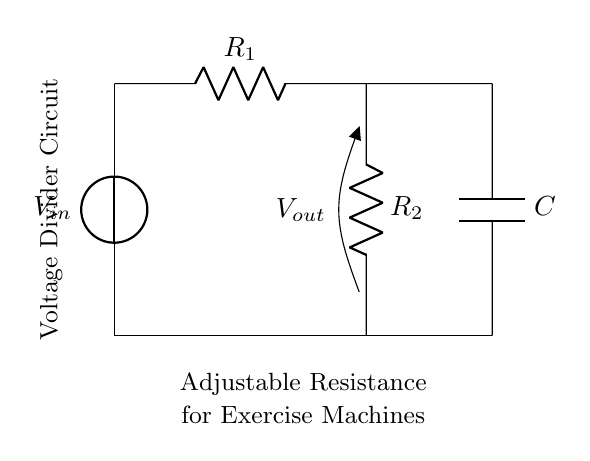What is the input voltage of the circuit? The input voltage, labeled as \( V_{in} \), is indicated at the top of the circuit. The specific numerical value isn't provided in the circuit diagram, but it represents the voltage supplied to the circuit.
Answer: \( V_{in} \) What are the two types of resistance in this circuit? The circuit contains two resistors: \( R_1 \) and \( R_2 \). These components are connected in series as part of a voltage divider, which adjusts resistance based on their values.
Answer: \( R_1 \) and \( R_2 \) What is the purpose of the capacitor in this circuit? The capacitor \( C \) in parallel with \( R_2 \) is used to smooth the output voltage or filter high-frequency signals, which can stabilize the performance of the exercise machine operation controlled by this circuit.
Answer: Smoothing/Filtering What is the voltage at the output of the circuit? The output voltage, labeled as \( V_{out} \), is taken across \( R_2 \) and represents the voltage level after the voltage divider action. This voltage can vary depending on the values of \( R_1 \) and \( R_2 \).
Answer: \( V_{out} \) How do the resistor values affect the output voltage? The output voltage \( V_{out} \) is determined using the voltage divider formula \( V_{out} = \frac{R_2}{R_1 + R_2} \cdot V_{in} \). Thus, changing either resistor value will modify \( V_{out} \): increasing \( R_2 \) increases \( V_{out} \), while increasing \( R_1 \) decreases it.
Answer: Through the voltage divider formula What characteristic defines this circuit as a voltage divider? This circuit is defined as a voltage divider because it uses two resistors in series, allowing for adjustable output voltage that is a fraction of the input voltage. This property is essential for applications requiring variable voltage levels, such as in exercise machines.
Answer: Two series resistors What is the role of the circuit in exercise machines? The role of the circuit is to provide adjustable resistance, allowing for variable tension or load in exercise machines, which can aid in the rehabilitation process for students with motor skill challenges.
Answer: Adjustable resistance for exercise machines 